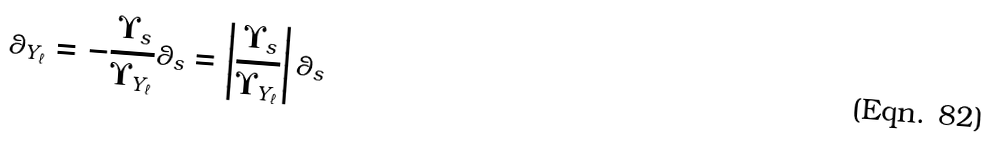<formula> <loc_0><loc_0><loc_500><loc_500>\theta _ { Y _ { \ell } } = - \frac { \Upsilon _ { s } } { \Upsilon _ { Y _ { \ell } } } \theta _ { s } = \left | \frac { \Upsilon _ { s } } { \Upsilon _ { Y _ { \ell } } } \right | \theta _ { s }</formula> 